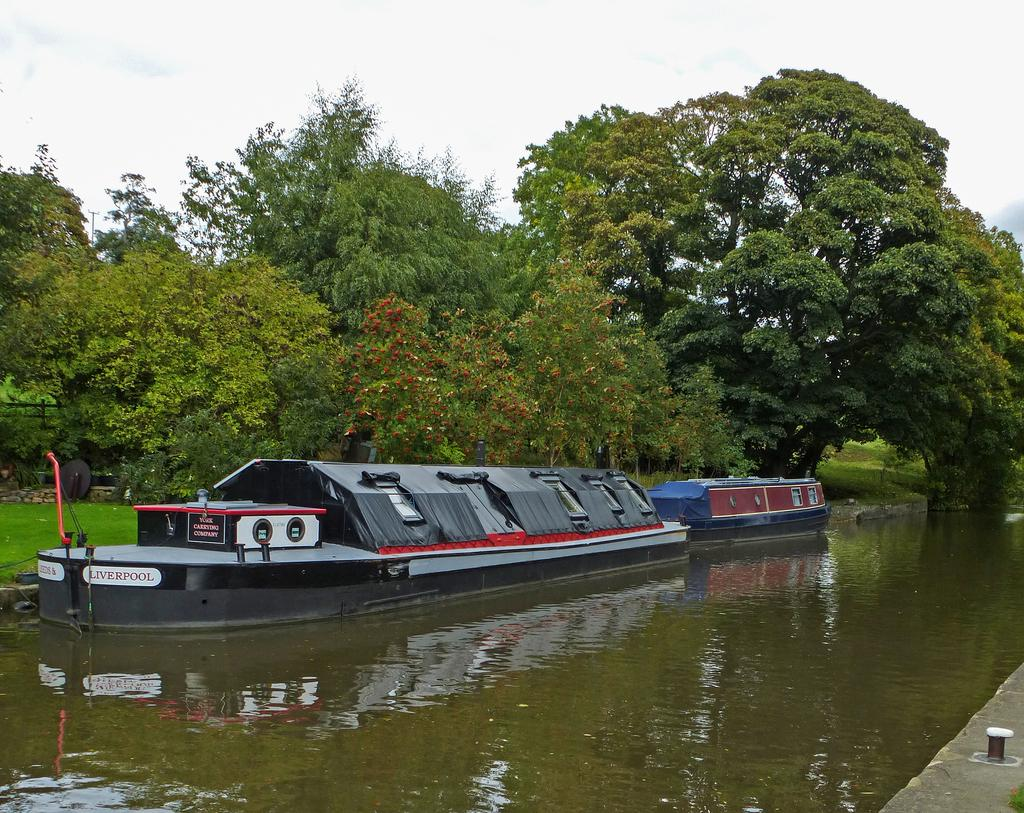What is on the water in the image? There are boats on the water in the image. What type of vegetation can be seen in the image? There are trees and grass in the image. What is visible in the background of the image? The sky is visible in the background of the image. Can you tell me how many people are joining the grass in the image? There is no indication of people joining the grass in the image; it is a natural landscape with no human presence. 